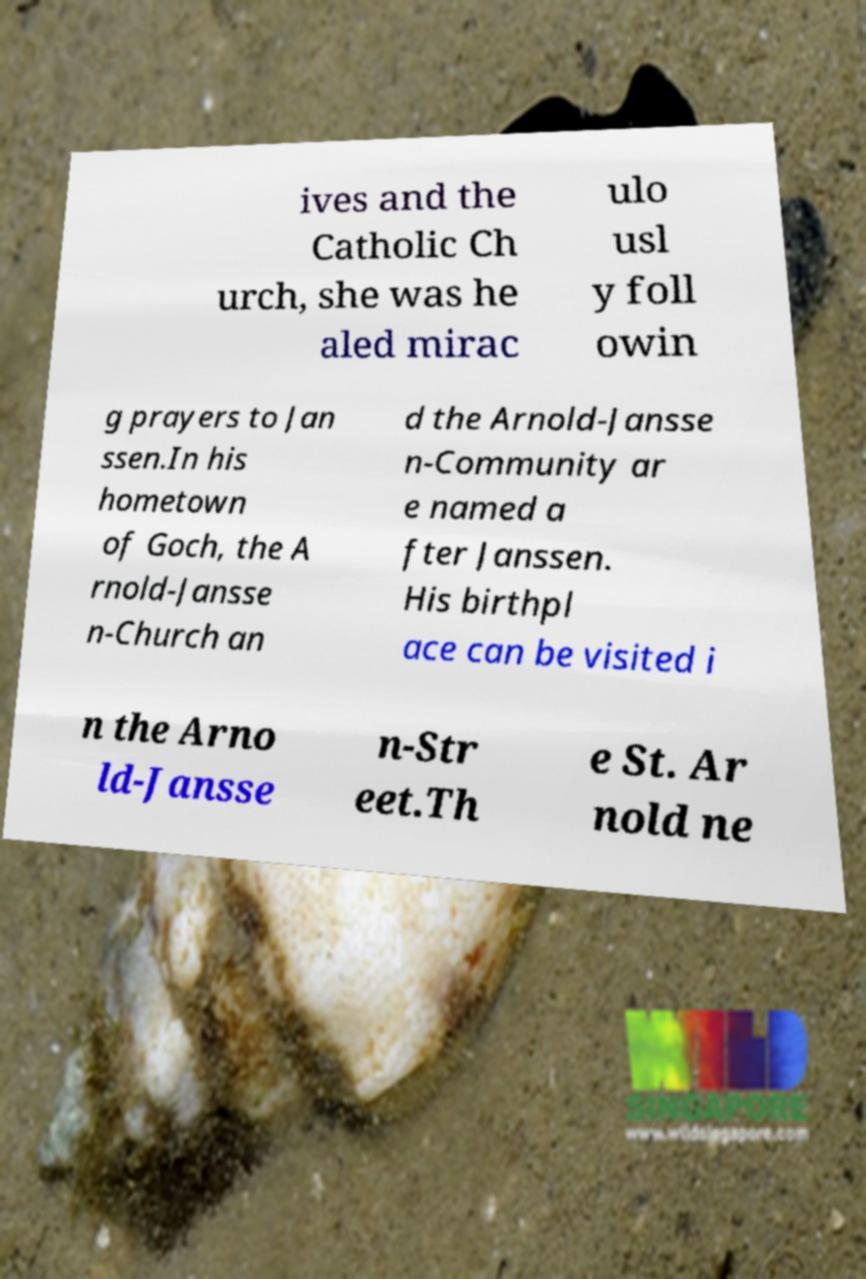There's text embedded in this image that I need extracted. Can you transcribe it verbatim? ives and the Catholic Ch urch, she was he aled mirac ulo usl y foll owin g prayers to Jan ssen.In his hometown of Goch, the A rnold-Jansse n-Church an d the Arnold-Jansse n-Community ar e named a fter Janssen. His birthpl ace can be visited i n the Arno ld-Jansse n-Str eet.Th e St. Ar nold ne 